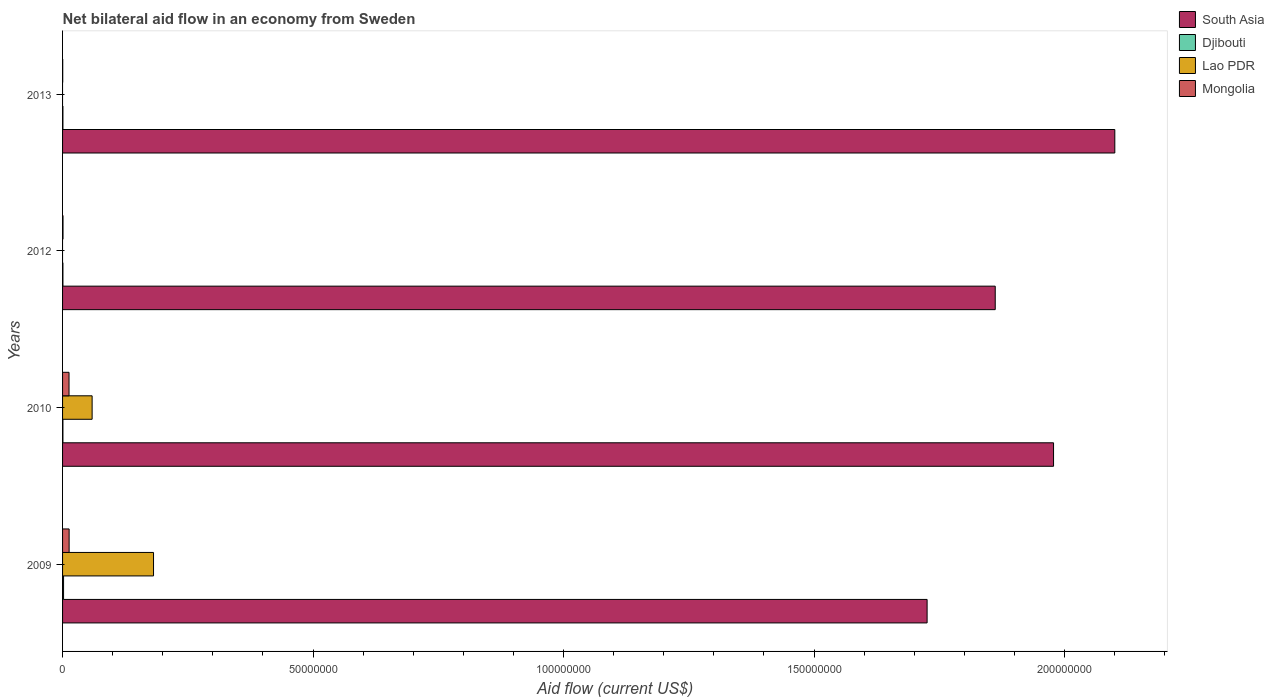How many different coloured bars are there?
Offer a very short reply. 4. Are the number of bars on each tick of the Y-axis equal?
Your answer should be very brief. No. How many bars are there on the 1st tick from the top?
Make the answer very short. 3. In how many cases, is the number of bars for a given year not equal to the number of legend labels?
Your response must be concise. 2. Across all years, what is the maximum net bilateral aid flow in Mongolia?
Offer a terse response. 1.31e+06. Across all years, what is the minimum net bilateral aid flow in South Asia?
Ensure brevity in your answer.  1.73e+08. What is the total net bilateral aid flow in Mongolia in the graph?
Make the answer very short. 2.72e+06. What is the difference between the net bilateral aid flow in South Asia in 2010 and that in 2013?
Keep it short and to the point. -1.22e+07. What is the difference between the net bilateral aid flow in Lao PDR in 2010 and the net bilateral aid flow in South Asia in 2012?
Keep it short and to the point. -1.80e+08. What is the average net bilateral aid flow in South Asia per year?
Ensure brevity in your answer.  1.92e+08. In the year 2009, what is the difference between the net bilateral aid flow in Mongolia and net bilateral aid flow in Lao PDR?
Ensure brevity in your answer.  -1.68e+07. What is the ratio of the net bilateral aid flow in South Asia in 2010 to that in 2012?
Offer a very short reply. 1.06. What is the difference between the highest and the second highest net bilateral aid flow in Djibouti?
Your answer should be compact. 1.30e+05. What is the difference between the highest and the lowest net bilateral aid flow in South Asia?
Provide a short and direct response. 3.75e+07. Is it the case that in every year, the sum of the net bilateral aid flow in Lao PDR and net bilateral aid flow in South Asia is greater than the sum of net bilateral aid flow in Mongolia and net bilateral aid flow in Djibouti?
Provide a short and direct response. Yes. Is it the case that in every year, the sum of the net bilateral aid flow in Lao PDR and net bilateral aid flow in Djibouti is greater than the net bilateral aid flow in Mongolia?
Provide a short and direct response. No. How many years are there in the graph?
Your answer should be very brief. 4. What is the difference between two consecutive major ticks on the X-axis?
Your response must be concise. 5.00e+07. Does the graph contain any zero values?
Your response must be concise. Yes. How many legend labels are there?
Your answer should be very brief. 4. How are the legend labels stacked?
Your answer should be compact. Vertical. What is the title of the graph?
Offer a very short reply. Net bilateral aid flow in an economy from Sweden. Does "Panama" appear as one of the legend labels in the graph?
Make the answer very short. No. What is the label or title of the Y-axis?
Make the answer very short. Years. What is the Aid flow (current US$) of South Asia in 2009?
Ensure brevity in your answer.  1.73e+08. What is the Aid flow (current US$) in Lao PDR in 2009?
Your answer should be very brief. 1.82e+07. What is the Aid flow (current US$) of Mongolia in 2009?
Offer a terse response. 1.31e+06. What is the Aid flow (current US$) of South Asia in 2010?
Keep it short and to the point. 1.98e+08. What is the Aid flow (current US$) in Lao PDR in 2010?
Give a very brief answer. 5.90e+06. What is the Aid flow (current US$) in Mongolia in 2010?
Ensure brevity in your answer.  1.29e+06. What is the Aid flow (current US$) in South Asia in 2012?
Keep it short and to the point. 1.86e+08. What is the Aid flow (current US$) of Djibouti in 2012?
Provide a short and direct response. 7.00e+04. What is the Aid flow (current US$) of Mongolia in 2012?
Offer a terse response. 9.00e+04. What is the Aid flow (current US$) in South Asia in 2013?
Your answer should be very brief. 2.10e+08. Across all years, what is the maximum Aid flow (current US$) of South Asia?
Keep it short and to the point. 2.10e+08. Across all years, what is the maximum Aid flow (current US$) in Lao PDR?
Your response must be concise. 1.82e+07. Across all years, what is the maximum Aid flow (current US$) of Mongolia?
Your answer should be compact. 1.31e+06. Across all years, what is the minimum Aid flow (current US$) of South Asia?
Give a very brief answer. 1.73e+08. Across all years, what is the minimum Aid flow (current US$) in Lao PDR?
Make the answer very short. 0. Across all years, what is the minimum Aid flow (current US$) in Mongolia?
Offer a terse response. 3.00e+04. What is the total Aid flow (current US$) in South Asia in the graph?
Make the answer very short. 7.67e+08. What is the total Aid flow (current US$) in Lao PDR in the graph?
Your answer should be very brief. 2.41e+07. What is the total Aid flow (current US$) in Mongolia in the graph?
Ensure brevity in your answer.  2.72e+06. What is the difference between the Aid flow (current US$) of South Asia in 2009 and that in 2010?
Your answer should be very brief. -2.52e+07. What is the difference between the Aid flow (current US$) in Djibouti in 2009 and that in 2010?
Give a very brief answer. 1.30e+05. What is the difference between the Aid flow (current US$) in Lao PDR in 2009 and that in 2010?
Ensure brevity in your answer.  1.23e+07. What is the difference between the Aid flow (current US$) in South Asia in 2009 and that in 2012?
Provide a succinct answer. -1.36e+07. What is the difference between the Aid flow (current US$) of Mongolia in 2009 and that in 2012?
Ensure brevity in your answer.  1.22e+06. What is the difference between the Aid flow (current US$) of South Asia in 2009 and that in 2013?
Provide a succinct answer. -3.75e+07. What is the difference between the Aid flow (current US$) in Mongolia in 2009 and that in 2013?
Your answer should be very brief. 1.28e+06. What is the difference between the Aid flow (current US$) in South Asia in 2010 and that in 2012?
Offer a terse response. 1.16e+07. What is the difference between the Aid flow (current US$) in Djibouti in 2010 and that in 2012?
Ensure brevity in your answer.  0. What is the difference between the Aid flow (current US$) of Mongolia in 2010 and that in 2012?
Offer a very short reply. 1.20e+06. What is the difference between the Aid flow (current US$) of South Asia in 2010 and that in 2013?
Your answer should be compact. -1.22e+07. What is the difference between the Aid flow (current US$) in Djibouti in 2010 and that in 2013?
Offer a very short reply. 0. What is the difference between the Aid flow (current US$) in Mongolia in 2010 and that in 2013?
Ensure brevity in your answer.  1.26e+06. What is the difference between the Aid flow (current US$) of South Asia in 2012 and that in 2013?
Your response must be concise. -2.39e+07. What is the difference between the Aid flow (current US$) of Mongolia in 2012 and that in 2013?
Your answer should be compact. 6.00e+04. What is the difference between the Aid flow (current US$) of South Asia in 2009 and the Aid flow (current US$) of Djibouti in 2010?
Ensure brevity in your answer.  1.73e+08. What is the difference between the Aid flow (current US$) in South Asia in 2009 and the Aid flow (current US$) in Lao PDR in 2010?
Keep it short and to the point. 1.67e+08. What is the difference between the Aid flow (current US$) of South Asia in 2009 and the Aid flow (current US$) of Mongolia in 2010?
Give a very brief answer. 1.71e+08. What is the difference between the Aid flow (current US$) of Djibouti in 2009 and the Aid flow (current US$) of Lao PDR in 2010?
Your response must be concise. -5.70e+06. What is the difference between the Aid flow (current US$) of Djibouti in 2009 and the Aid flow (current US$) of Mongolia in 2010?
Your answer should be compact. -1.09e+06. What is the difference between the Aid flow (current US$) in Lao PDR in 2009 and the Aid flow (current US$) in Mongolia in 2010?
Your answer should be compact. 1.69e+07. What is the difference between the Aid flow (current US$) of South Asia in 2009 and the Aid flow (current US$) of Djibouti in 2012?
Your response must be concise. 1.73e+08. What is the difference between the Aid flow (current US$) of South Asia in 2009 and the Aid flow (current US$) of Mongolia in 2012?
Make the answer very short. 1.72e+08. What is the difference between the Aid flow (current US$) of Djibouti in 2009 and the Aid flow (current US$) of Mongolia in 2012?
Offer a terse response. 1.10e+05. What is the difference between the Aid flow (current US$) in Lao PDR in 2009 and the Aid flow (current US$) in Mongolia in 2012?
Your answer should be compact. 1.81e+07. What is the difference between the Aid flow (current US$) in South Asia in 2009 and the Aid flow (current US$) in Djibouti in 2013?
Provide a short and direct response. 1.73e+08. What is the difference between the Aid flow (current US$) of South Asia in 2009 and the Aid flow (current US$) of Mongolia in 2013?
Offer a very short reply. 1.73e+08. What is the difference between the Aid flow (current US$) in Lao PDR in 2009 and the Aid flow (current US$) in Mongolia in 2013?
Give a very brief answer. 1.81e+07. What is the difference between the Aid flow (current US$) of South Asia in 2010 and the Aid flow (current US$) of Djibouti in 2012?
Offer a terse response. 1.98e+08. What is the difference between the Aid flow (current US$) in South Asia in 2010 and the Aid flow (current US$) in Mongolia in 2012?
Your response must be concise. 1.98e+08. What is the difference between the Aid flow (current US$) of Lao PDR in 2010 and the Aid flow (current US$) of Mongolia in 2012?
Provide a short and direct response. 5.81e+06. What is the difference between the Aid flow (current US$) of South Asia in 2010 and the Aid flow (current US$) of Djibouti in 2013?
Offer a very short reply. 1.98e+08. What is the difference between the Aid flow (current US$) of South Asia in 2010 and the Aid flow (current US$) of Mongolia in 2013?
Keep it short and to the point. 1.98e+08. What is the difference between the Aid flow (current US$) in Djibouti in 2010 and the Aid flow (current US$) in Mongolia in 2013?
Make the answer very short. 4.00e+04. What is the difference between the Aid flow (current US$) of Lao PDR in 2010 and the Aid flow (current US$) of Mongolia in 2013?
Offer a terse response. 5.87e+06. What is the difference between the Aid flow (current US$) of South Asia in 2012 and the Aid flow (current US$) of Djibouti in 2013?
Provide a succinct answer. 1.86e+08. What is the difference between the Aid flow (current US$) in South Asia in 2012 and the Aid flow (current US$) in Mongolia in 2013?
Your response must be concise. 1.86e+08. What is the difference between the Aid flow (current US$) in Djibouti in 2012 and the Aid flow (current US$) in Mongolia in 2013?
Offer a very short reply. 4.00e+04. What is the average Aid flow (current US$) in South Asia per year?
Your answer should be very brief. 1.92e+08. What is the average Aid flow (current US$) in Djibouti per year?
Keep it short and to the point. 1.02e+05. What is the average Aid flow (current US$) in Lao PDR per year?
Ensure brevity in your answer.  6.02e+06. What is the average Aid flow (current US$) of Mongolia per year?
Offer a terse response. 6.80e+05. In the year 2009, what is the difference between the Aid flow (current US$) in South Asia and Aid flow (current US$) in Djibouti?
Your response must be concise. 1.72e+08. In the year 2009, what is the difference between the Aid flow (current US$) in South Asia and Aid flow (current US$) in Lao PDR?
Make the answer very short. 1.54e+08. In the year 2009, what is the difference between the Aid flow (current US$) in South Asia and Aid flow (current US$) in Mongolia?
Your response must be concise. 1.71e+08. In the year 2009, what is the difference between the Aid flow (current US$) in Djibouti and Aid flow (current US$) in Lao PDR?
Ensure brevity in your answer.  -1.80e+07. In the year 2009, what is the difference between the Aid flow (current US$) in Djibouti and Aid flow (current US$) in Mongolia?
Offer a terse response. -1.11e+06. In the year 2009, what is the difference between the Aid flow (current US$) of Lao PDR and Aid flow (current US$) of Mongolia?
Provide a short and direct response. 1.68e+07. In the year 2010, what is the difference between the Aid flow (current US$) of South Asia and Aid flow (current US$) of Djibouti?
Ensure brevity in your answer.  1.98e+08. In the year 2010, what is the difference between the Aid flow (current US$) of South Asia and Aid flow (current US$) of Lao PDR?
Ensure brevity in your answer.  1.92e+08. In the year 2010, what is the difference between the Aid flow (current US$) in South Asia and Aid flow (current US$) in Mongolia?
Your response must be concise. 1.97e+08. In the year 2010, what is the difference between the Aid flow (current US$) of Djibouti and Aid flow (current US$) of Lao PDR?
Give a very brief answer. -5.83e+06. In the year 2010, what is the difference between the Aid flow (current US$) of Djibouti and Aid flow (current US$) of Mongolia?
Provide a succinct answer. -1.22e+06. In the year 2010, what is the difference between the Aid flow (current US$) of Lao PDR and Aid flow (current US$) of Mongolia?
Offer a terse response. 4.61e+06. In the year 2012, what is the difference between the Aid flow (current US$) in South Asia and Aid flow (current US$) in Djibouti?
Keep it short and to the point. 1.86e+08. In the year 2012, what is the difference between the Aid flow (current US$) of South Asia and Aid flow (current US$) of Mongolia?
Your answer should be very brief. 1.86e+08. In the year 2012, what is the difference between the Aid flow (current US$) of Djibouti and Aid flow (current US$) of Mongolia?
Provide a short and direct response. -2.00e+04. In the year 2013, what is the difference between the Aid flow (current US$) of South Asia and Aid flow (current US$) of Djibouti?
Keep it short and to the point. 2.10e+08. In the year 2013, what is the difference between the Aid flow (current US$) in South Asia and Aid flow (current US$) in Mongolia?
Ensure brevity in your answer.  2.10e+08. In the year 2013, what is the difference between the Aid flow (current US$) of Djibouti and Aid flow (current US$) of Mongolia?
Give a very brief answer. 4.00e+04. What is the ratio of the Aid flow (current US$) in South Asia in 2009 to that in 2010?
Provide a succinct answer. 0.87. What is the ratio of the Aid flow (current US$) of Djibouti in 2009 to that in 2010?
Your answer should be very brief. 2.86. What is the ratio of the Aid flow (current US$) of Lao PDR in 2009 to that in 2010?
Your response must be concise. 3.08. What is the ratio of the Aid flow (current US$) in Mongolia in 2009 to that in 2010?
Provide a succinct answer. 1.02. What is the ratio of the Aid flow (current US$) of South Asia in 2009 to that in 2012?
Provide a short and direct response. 0.93. What is the ratio of the Aid flow (current US$) in Djibouti in 2009 to that in 2012?
Give a very brief answer. 2.86. What is the ratio of the Aid flow (current US$) of Mongolia in 2009 to that in 2012?
Your answer should be compact. 14.56. What is the ratio of the Aid flow (current US$) of South Asia in 2009 to that in 2013?
Ensure brevity in your answer.  0.82. What is the ratio of the Aid flow (current US$) of Djibouti in 2009 to that in 2013?
Ensure brevity in your answer.  2.86. What is the ratio of the Aid flow (current US$) of Mongolia in 2009 to that in 2013?
Provide a succinct answer. 43.67. What is the ratio of the Aid flow (current US$) in South Asia in 2010 to that in 2012?
Offer a very short reply. 1.06. What is the ratio of the Aid flow (current US$) in Djibouti in 2010 to that in 2012?
Ensure brevity in your answer.  1. What is the ratio of the Aid flow (current US$) in Mongolia in 2010 to that in 2012?
Your answer should be compact. 14.33. What is the ratio of the Aid flow (current US$) of South Asia in 2010 to that in 2013?
Give a very brief answer. 0.94. What is the ratio of the Aid flow (current US$) of South Asia in 2012 to that in 2013?
Give a very brief answer. 0.89. What is the ratio of the Aid flow (current US$) in Mongolia in 2012 to that in 2013?
Your response must be concise. 3. What is the difference between the highest and the second highest Aid flow (current US$) in South Asia?
Provide a short and direct response. 1.22e+07. What is the difference between the highest and the second highest Aid flow (current US$) of Mongolia?
Your response must be concise. 2.00e+04. What is the difference between the highest and the lowest Aid flow (current US$) of South Asia?
Give a very brief answer. 3.75e+07. What is the difference between the highest and the lowest Aid flow (current US$) of Djibouti?
Provide a short and direct response. 1.30e+05. What is the difference between the highest and the lowest Aid flow (current US$) of Lao PDR?
Your answer should be compact. 1.82e+07. What is the difference between the highest and the lowest Aid flow (current US$) of Mongolia?
Your response must be concise. 1.28e+06. 